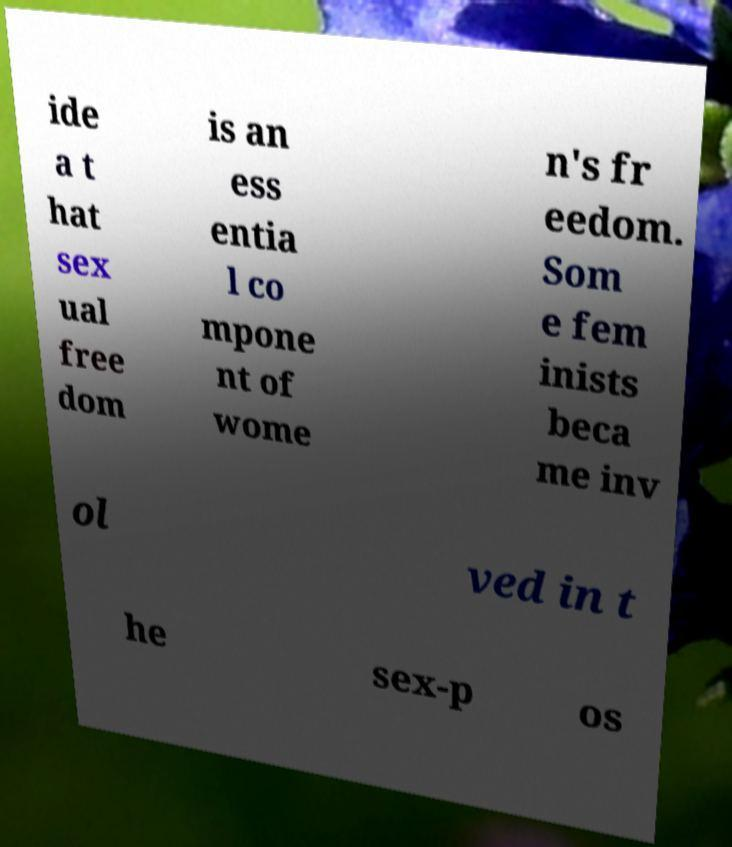For documentation purposes, I need the text within this image transcribed. Could you provide that? ide a t hat sex ual free dom is an ess entia l co mpone nt of wome n's fr eedom. Som e fem inists beca me inv ol ved in t he sex-p os 